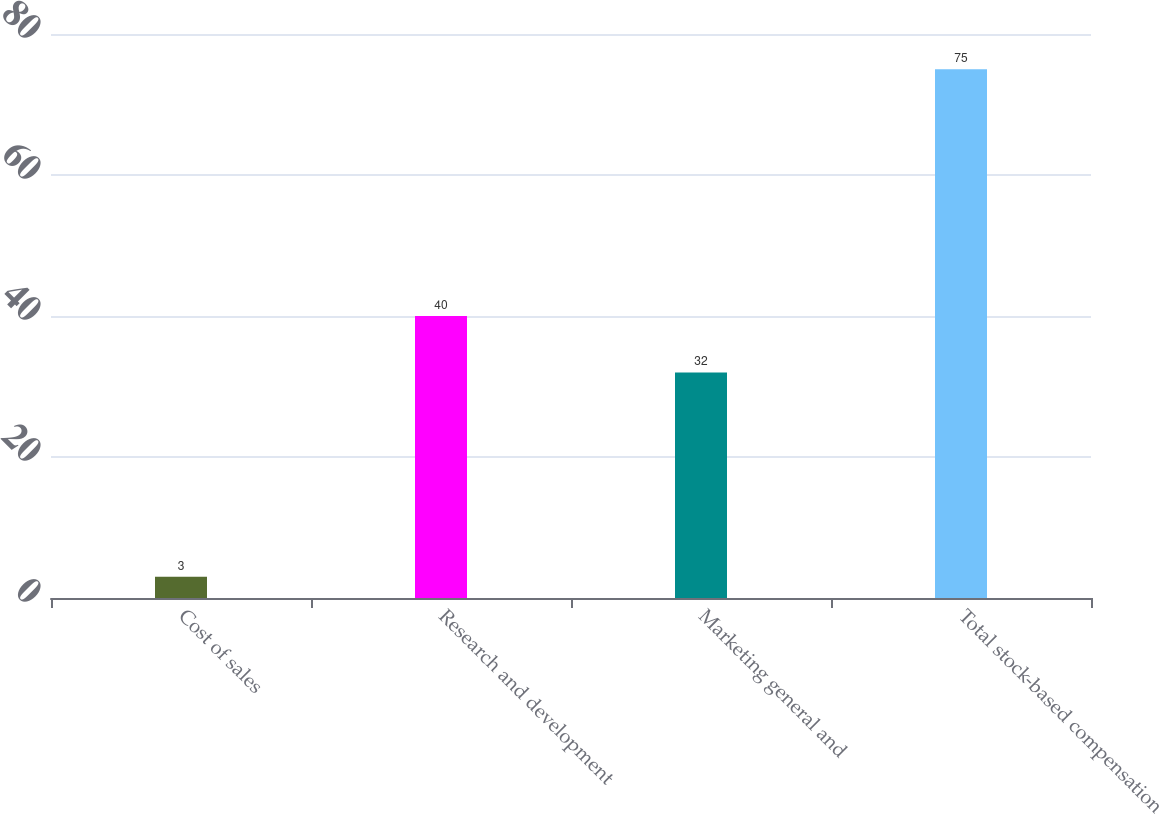Convert chart to OTSL. <chart><loc_0><loc_0><loc_500><loc_500><bar_chart><fcel>Cost of sales<fcel>Research and development<fcel>Marketing general and<fcel>Total stock-based compensation<nl><fcel>3<fcel>40<fcel>32<fcel>75<nl></chart> 